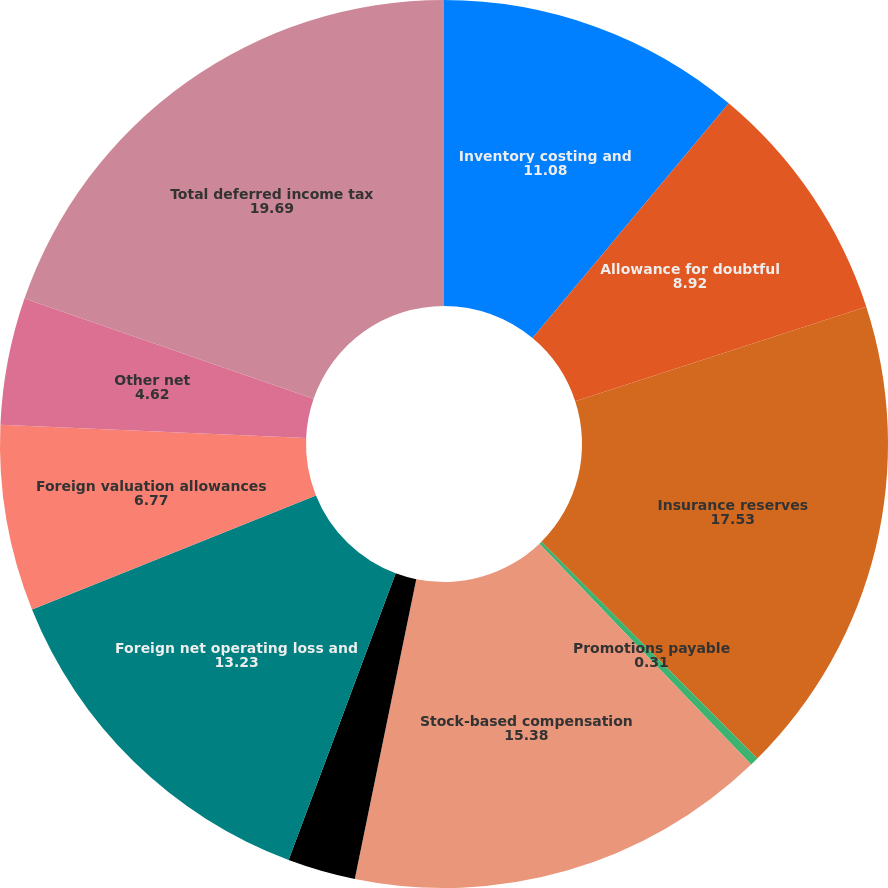Convert chart to OTSL. <chart><loc_0><loc_0><loc_500><loc_500><pie_chart><fcel>Inventory costing and<fcel>Allowance for doubtful<fcel>Insurance reserves<fcel>Promotions payable<fcel>Stock-based compensation<fcel>Federal and state benefit of<fcel>Foreign net operating loss and<fcel>Foreign valuation allowances<fcel>Other net<fcel>Total deferred income tax<nl><fcel>11.08%<fcel>8.92%<fcel>17.53%<fcel>0.31%<fcel>15.38%<fcel>2.47%<fcel>13.23%<fcel>6.77%<fcel>4.62%<fcel>19.69%<nl></chart> 